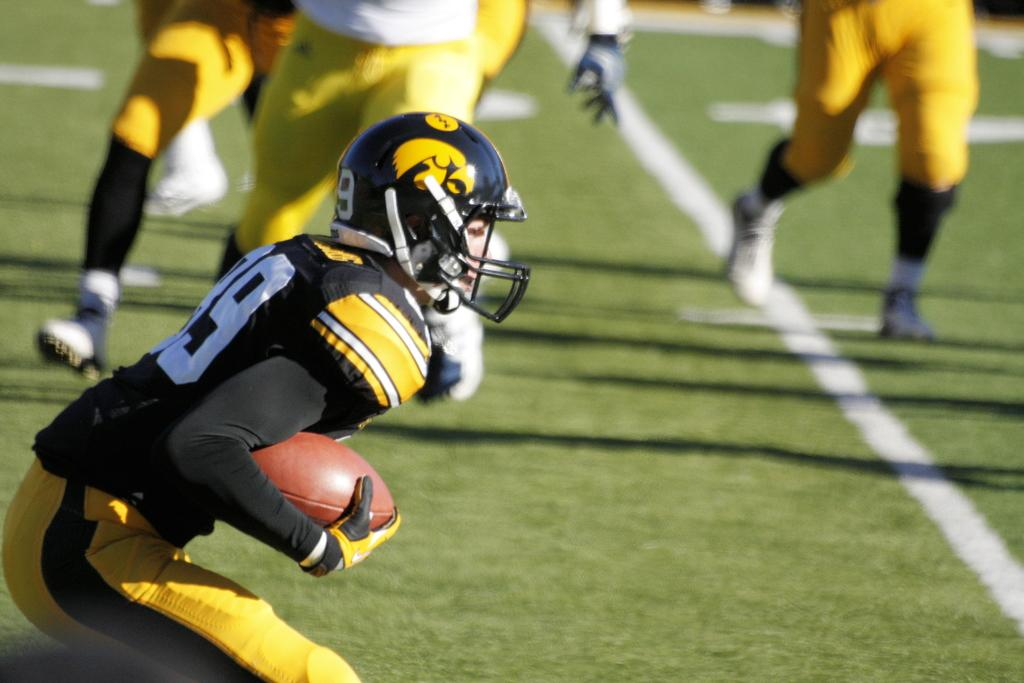What is the main subject on the left side of the image? There is a Rugby player standing on the left side of the image. What is the Rugby player holding? The player is holding a Rugby ball. What protective gear is the player wearing? The player is wearing a helmet. What are the other players in the image doing? The other players are running in the middle of the image. What type of pig can be seen running alongside the Rugby players in the image? There is no pig present in the image; it features only Rugby players. What page is the Rugby player turning to in the image? The image does not depict a page or any reading material; it is a photograph of Rugby players. 